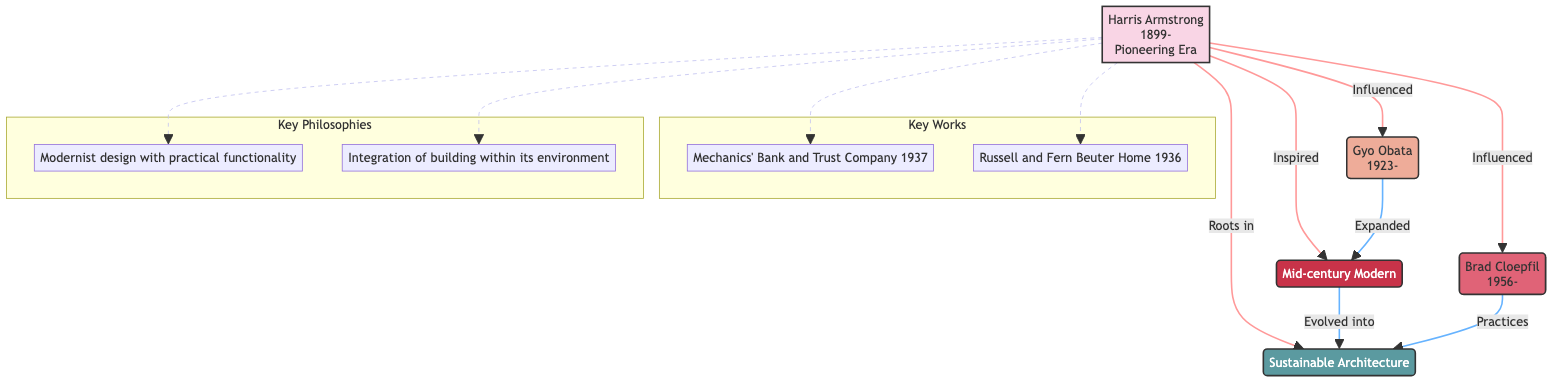What year was Harris Armstrong born? The node representing Harris Armstrong in the diagram states that he was born in the year 1899.
Answer: 1899 Who is a second-generation architect influenced by Harris Armstrong? The diagram indicates that Gyo Obata is a second-generation architect who worked under Harris Armstrong.
Answer: Gyo Obata What architectural movement is influenced by Harris Armstrong's work? The node for the Mid-century Modern movement shows that it was influenced by Harris Armstrong's pioneering work.
Answer: Mid-century Modern What notable work did Gyo Obata design? The diagram lists the National Air and Space Museum as one of Gyo Obata's notable works, indicating his contribution to architecture.
Answer: National Air and Space Museum How many notable works are listed for Harris Armstrong? There are two notable works (Mechanics' Bank and Trust Company and Russell and Fern Beuter Home) mentioned in the diagram connected to Harris Armstrong.
Answer: 2 Which generation includes Brad Cloepfil? The diagram shows Brad Cloepfil as a part of the third generation of architects.
Answer: Third Generation What trend evolved from the Mid-century Modern movement? The diagram indicates that Sustainable Architecture evolved from the Mid-century Modern movement, showing a connection between these concepts.
Answer: Sustainable Architecture What is a key philosophy associated with Harris Armstrong? The diagram specifies that one of Harris Armstrong's key philosophies is the integration of building within its environment.
Answer: Integration of building within its environment How is Brad Cloepfil connected to the concept of Sustainable Architecture? The diagram illustrates that Brad Cloepfil's practices are linked to the trend of Sustainable Architecture, emphasizing the evolution from earlier philosophies.
Answer: Practices 